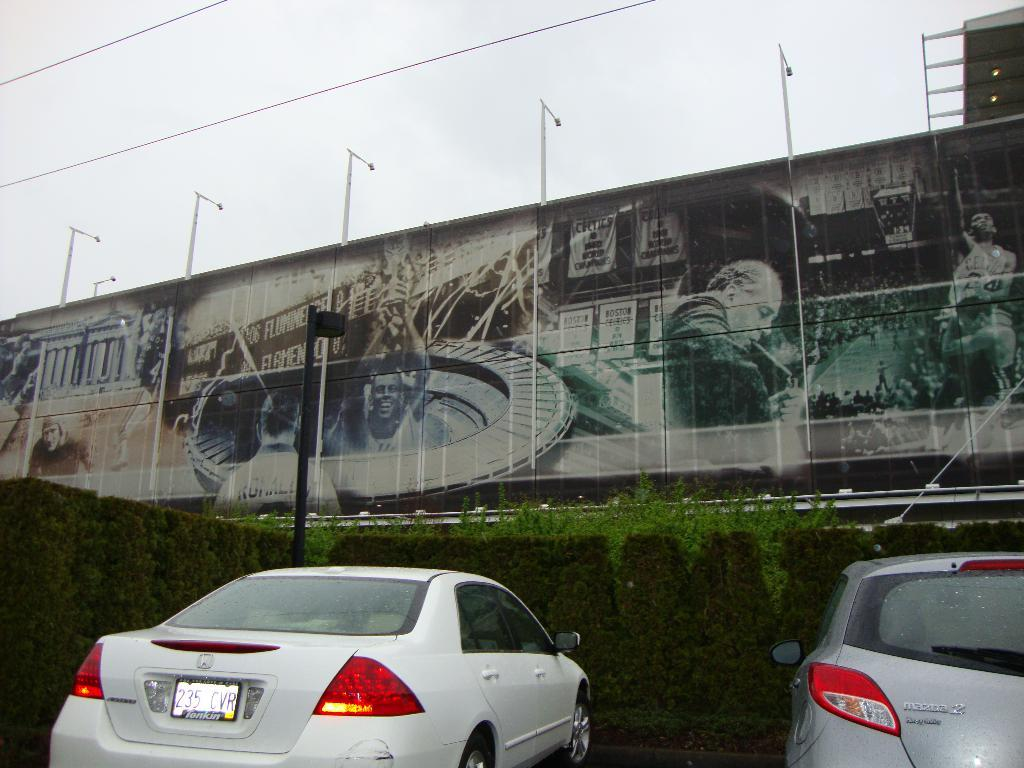How many vehicles are present in the image? There are two vehicles in the image. Where are the vehicles located? The vehicles are placed on the ground. What can be seen in the background of the image? There is a group of plants and a hoarding with a group of poles in the background of the image. What is visible in the sky in the image? The sky is visible in the background of the image. What type of lumber is being rolled across the vehicles in the image? There is no lumber or rolling action present in the image. What is the desire of the vehicles in the image? Vehicles do not have desires, as they are inanimate objects. 